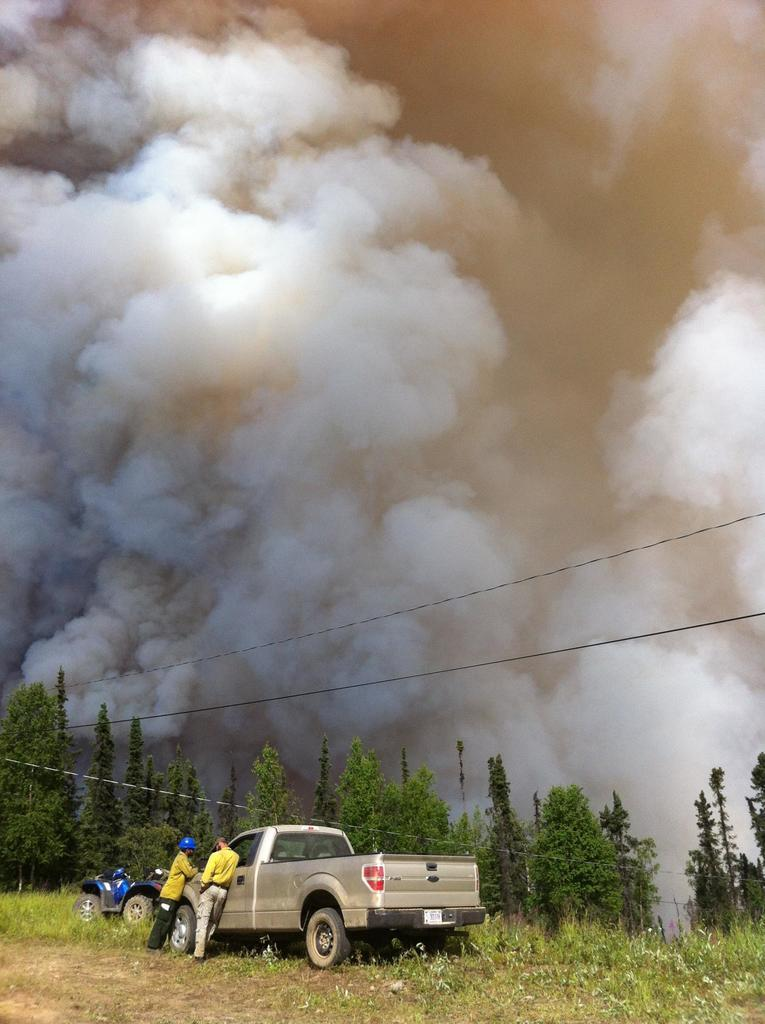What vehicles are at the bottom of the image? There are trucks at the bottom of the image. Who is present at the bottom of the image? There are two persons at the bottom of the image. What type of vegetation is visible in the image? Trees are present in the image. What type of ground is visible in the image? Grass is visible in the image. What is the surface on which the trucks and persons are standing? The ground is visible in the image. What else is present in the image besides the trucks, persons, and vegetation? Wires are present in the image. What can be seen at the top of the image? Fumes are present at the top of the image. Can you tell me how many goats are depicted in the image? There are no goats present in the image. What type of cream is being used by the persons in the image? There is no cream visible or mentioned in the image. 